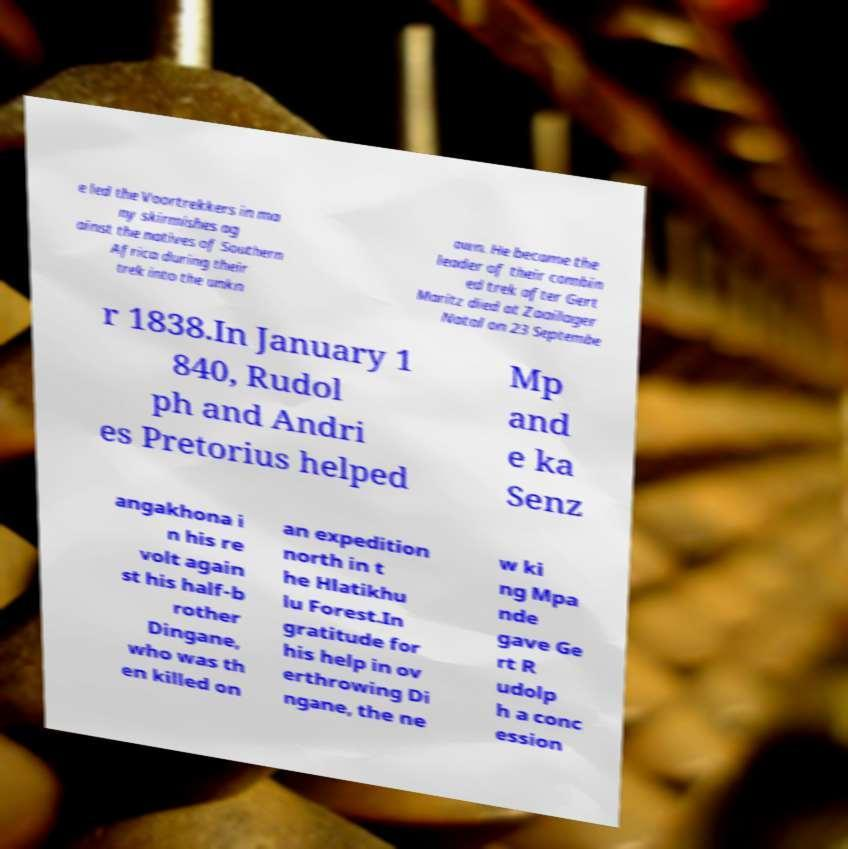Can you accurately transcribe the text from the provided image for me? e led the Voortrekkers in ma ny skirmishes ag ainst the natives of Southern Africa during their trek into the unkn own. He became the leader of their combin ed trek after Gert Maritz died at Zaailager Natal on 23 Septembe r 1838.In January 1 840, Rudol ph and Andri es Pretorius helped Mp and e ka Senz angakhona i n his re volt again st his half-b rother Dingane, who was th en killed on an expedition north in t he Hlatikhu lu Forest.In gratitude for his help in ov erthrowing Di ngane, the ne w ki ng Mpa nde gave Ge rt R udolp h a conc ession 